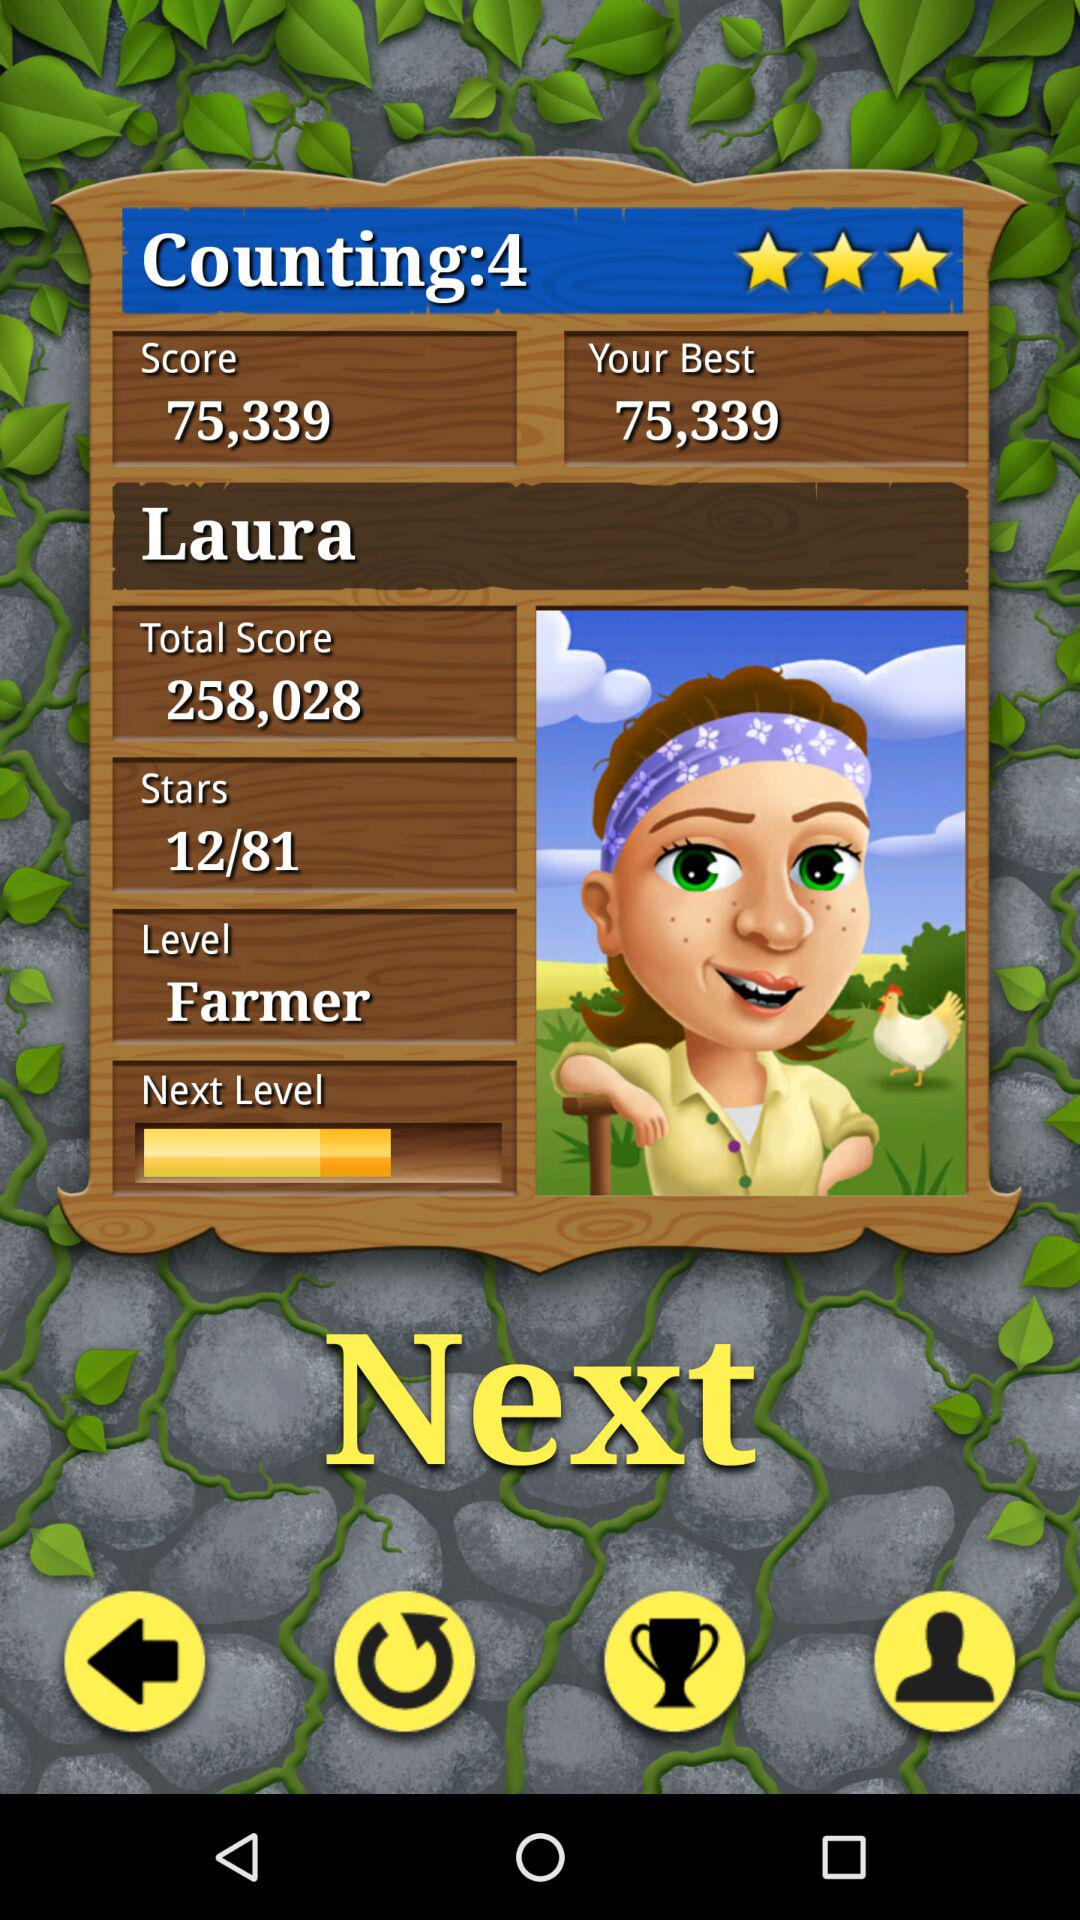What is the total score? The total score is 258,028. 